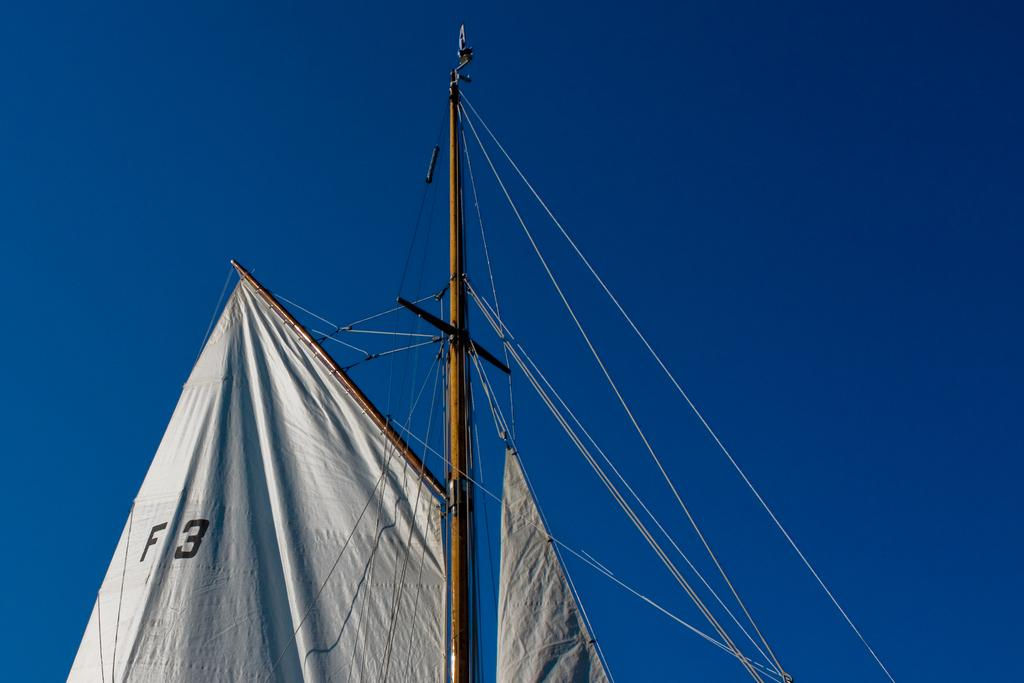<image>
Describe the image concisely. F3 is on the white sail of a boat against a blue sky. 